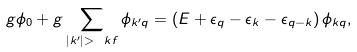<formula> <loc_0><loc_0><loc_500><loc_500>g \phi _ { 0 } + g \sum _ { | k ^ { \prime } | > \ k f } \phi _ { k ^ { \prime } q } = \left ( E + \epsilon _ { q } - \epsilon _ { k } - \epsilon _ { q - k } \right ) \phi _ { k q } ,</formula> 